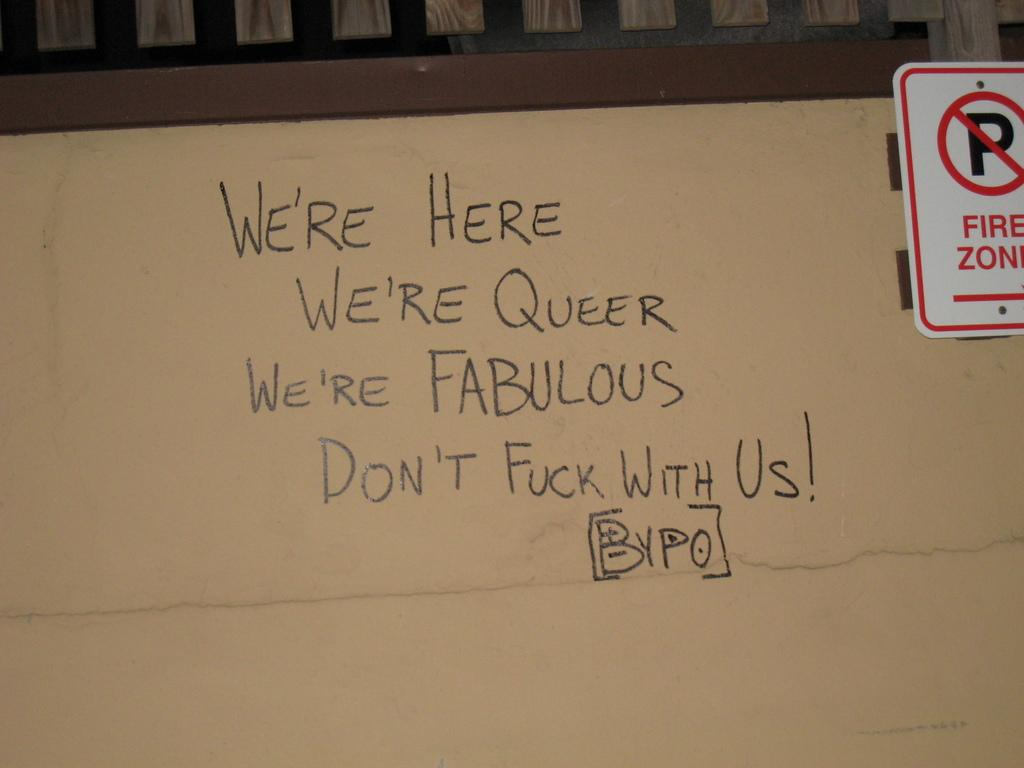<image>
Offer a succinct explanation of the picture presented. A red and white sign shows that this location if a fire zone. 